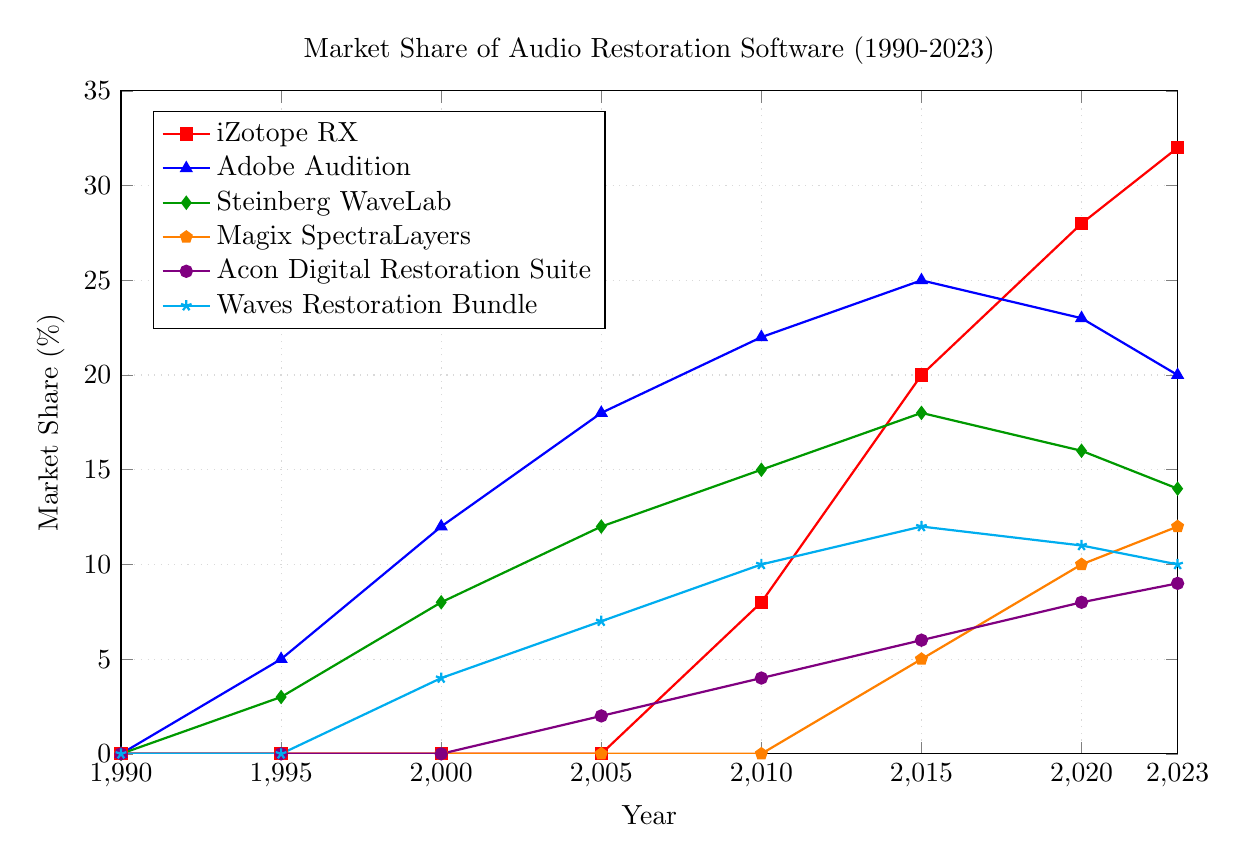What is the market share of iZotope RX in 2023? By looking at the orange pentagon-shaped markers in the year 2023, we can see the market share value.
Answer: 32% Which software had the highest market share in the year 2000? By comparing the values for each software in the year 2000, Adobe Audition has the highest market share.
Answer: Adobe Audition Has the market share of Steinberg WaveLab increased or decreased between 2015 and 2023? For Steinberg WaveLab, we observe the green diamond-shaped markers and compare the market share in 2015 (18%) and 2023 (14%).
Answer: Decreased What was the combined market share of Magix SpectraLayers and Acon Digital Restoration Suite in 2023? The market shares in 2023 are 12% for Magix SpectraLayers and 9% for Acon Digital Restoration Suite. Adding them together, 12% + 9%.
Answer: 21% Which software saw the most rapid growth after 2010? By examining all the lines, iZotope RX went from 8% in 2010 to 32% in 2023, showing the steepest increase.
Answer: iZotope RX Between 2005 and 2015, did any software see more than a 10% increase in market share? Comparing 2005 and 2015 for each software: Adobe Audition (18% to 25%), Waves Restoration Bundle (7% to 12%), and iZotope RX (0% to 20%) show increases above 10%.
Answer: Adobe Audition, Waves Restoration Bundle, iZotope RX What is the trend for the market share of Waves Restoration Bundle from 2000 to 2023? Observing the turquoise star-shaped markers for Waves Restoration Bundle, the market share rises from 2000 (4%) to a peak in 2015 (12%) before decreasing slightly by 2023 (10%).
Answer: Increasing, then slightly decreasing Which year did Acon Digital Restoration Suite first appear in the market, based on the chart? The violet circle-shaped markers for Acon Digital Restoration Suite first appear with a non-zero value in the year 2005.
Answer: 2005 How does the market share of Adobe Audition compare to iZotope RX in 2020? In 2020, Adobe Audition is at 23% while iZotope RX is at 28%. Comparing these shows iZotope RX has a higher share.
Answer: iZotope RX has a higher share By how many percentage points did the market share for Magix SpectraLayers increase from 2010 to 2023? Magix SpectraLayers had 0% in 2010 and 12% in 2023. The difference is 12% - 0%.
Answer: 12% 